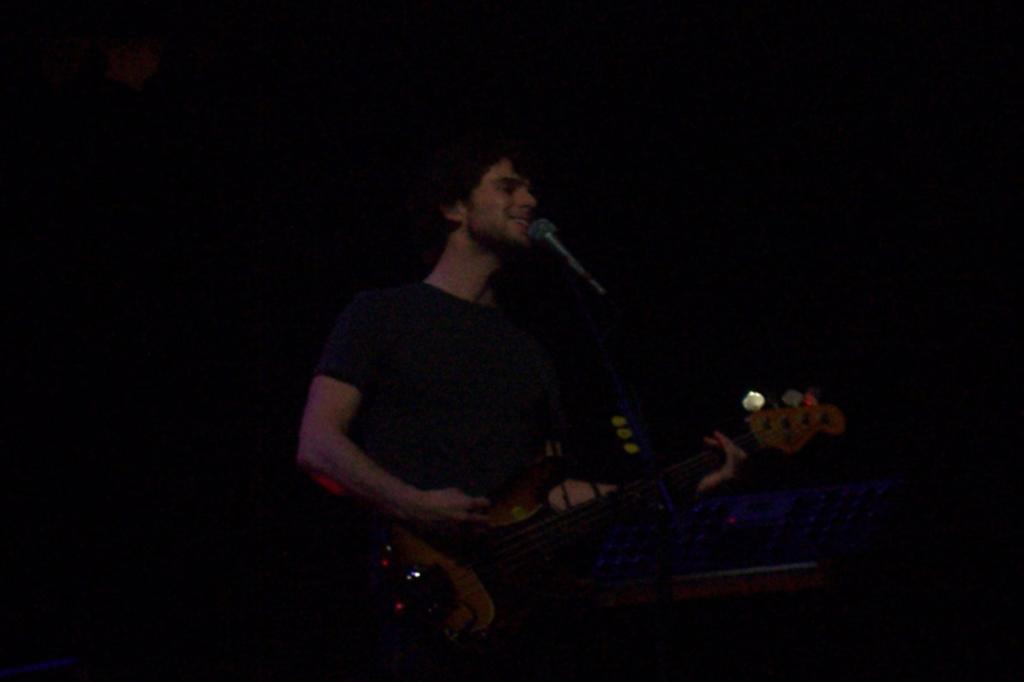What is the main subject of the image? The main subject of the image is a man. What is the man doing in the image? The man is playing a guitar in the image. What is the man's height in the image? The provided facts do not mention the man's height, so it cannot be determined from the image. 